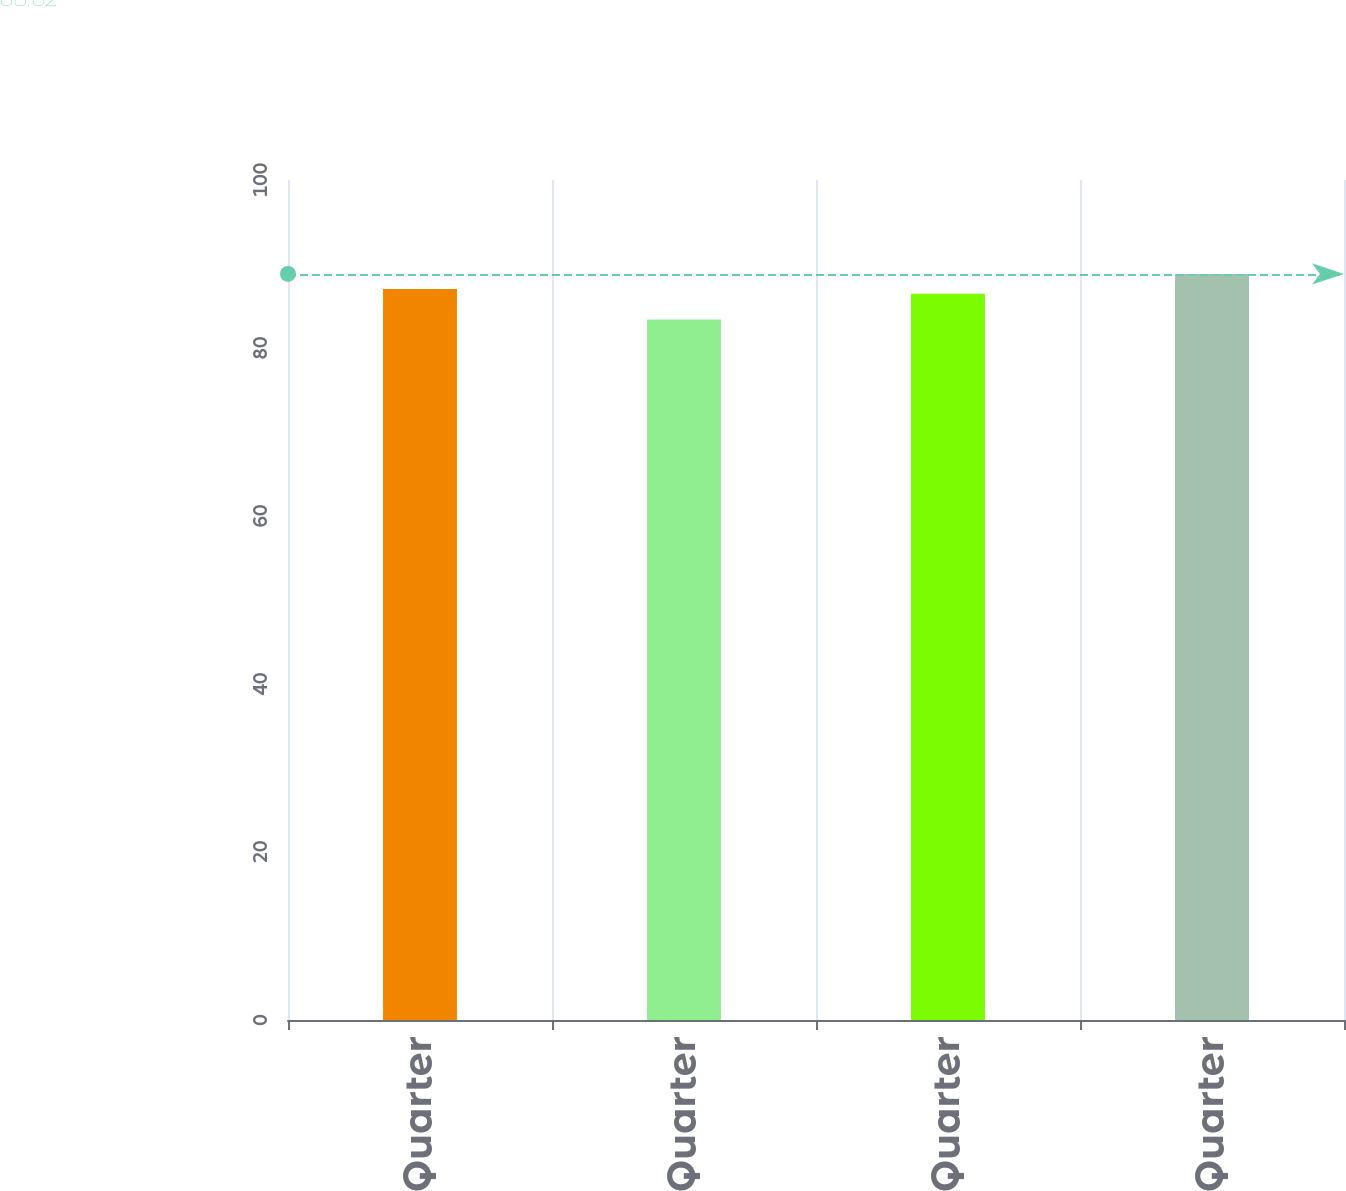<chart> <loc_0><loc_0><loc_500><loc_500><bar_chart><fcel>First Quarter<fcel>Second Quarter<fcel>Third Quarter<fcel>Fourth Quarter<nl><fcel>87.01<fcel>83.4<fcel>86.47<fcel>88.82<nl></chart> 